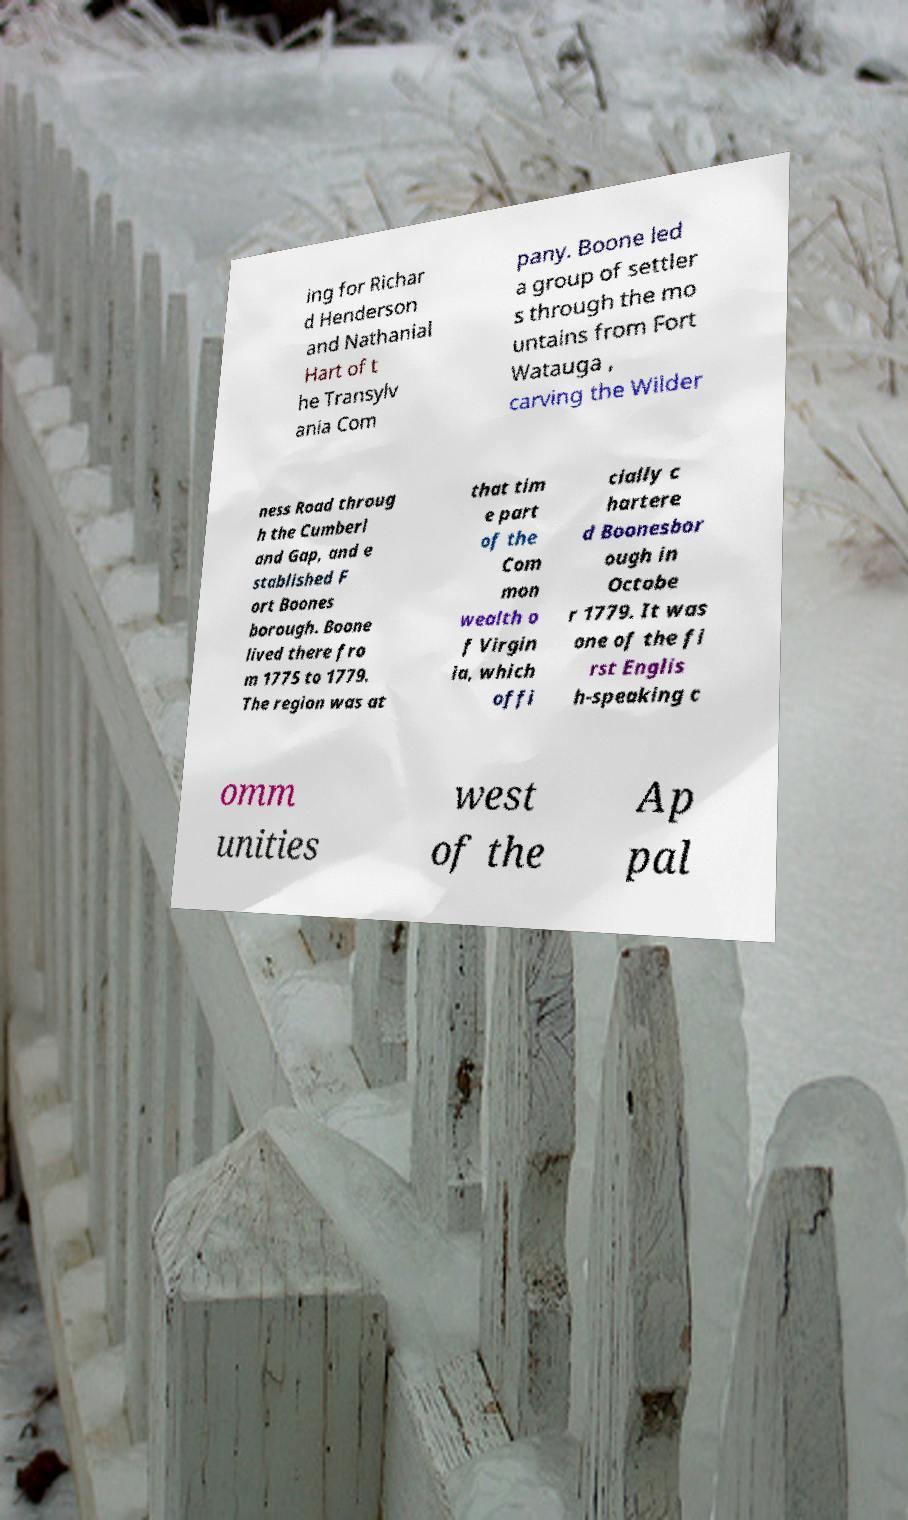Please read and relay the text visible in this image. What does it say? ing for Richar d Henderson and Nathanial Hart of t he Transylv ania Com pany. Boone led a group of settler s through the mo untains from Fort Watauga , carving the Wilder ness Road throug h the Cumberl and Gap, and e stablished F ort Boones borough. Boone lived there fro m 1775 to 1779. The region was at that tim e part of the Com mon wealth o f Virgin ia, which offi cially c hartere d Boonesbor ough in Octobe r 1779. It was one of the fi rst Englis h-speaking c omm unities west of the Ap pal 